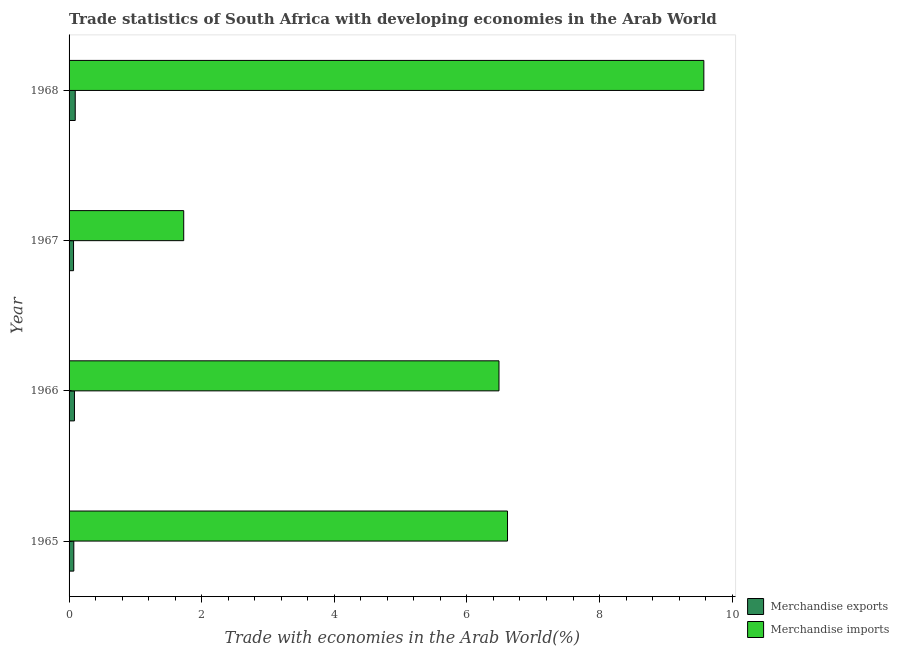Are the number of bars per tick equal to the number of legend labels?
Your answer should be very brief. Yes. How many bars are there on the 2nd tick from the bottom?
Your answer should be compact. 2. What is the label of the 3rd group of bars from the top?
Your response must be concise. 1966. In how many cases, is the number of bars for a given year not equal to the number of legend labels?
Make the answer very short. 0. What is the merchandise imports in 1965?
Ensure brevity in your answer.  6.61. Across all years, what is the maximum merchandise imports?
Keep it short and to the point. 9.57. Across all years, what is the minimum merchandise exports?
Ensure brevity in your answer.  0.07. In which year was the merchandise imports maximum?
Your answer should be very brief. 1968. In which year was the merchandise imports minimum?
Make the answer very short. 1967. What is the total merchandise imports in the graph?
Make the answer very short. 24.4. What is the difference between the merchandise exports in 1966 and that in 1967?
Make the answer very short. 0.01. What is the difference between the merchandise exports in 1967 and the merchandise imports in 1968?
Provide a succinct answer. -9.51. What is the average merchandise exports per year?
Ensure brevity in your answer.  0.08. In the year 1965, what is the difference between the merchandise exports and merchandise imports?
Your answer should be very brief. -6.54. In how many years, is the merchandise exports greater than 4 %?
Provide a short and direct response. 0. What is the ratio of the merchandise exports in 1966 to that in 1967?
Your answer should be compact. 1.21. Is the merchandise exports in 1965 less than that in 1967?
Provide a succinct answer. No. What is the difference between the highest and the second highest merchandise imports?
Your response must be concise. 2.96. What does the 2nd bar from the top in 1968 represents?
Your answer should be compact. Merchandise exports. What does the 2nd bar from the bottom in 1968 represents?
Give a very brief answer. Merchandise imports. How many bars are there?
Provide a short and direct response. 8. What is the difference between two consecutive major ticks on the X-axis?
Your response must be concise. 2. Are the values on the major ticks of X-axis written in scientific E-notation?
Ensure brevity in your answer.  No. Does the graph contain any zero values?
Offer a very short reply. No. How are the legend labels stacked?
Provide a short and direct response. Vertical. What is the title of the graph?
Your response must be concise. Trade statistics of South Africa with developing economies in the Arab World. What is the label or title of the X-axis?
Offer a terse response. Trade with economies in the Arab World(%). What is the label or title of the Y-axis?
Keep it short and to the point. Year. What is the Trade with economies in the Arab World(%) of Merchandise exports in 1965?
Provide a short and direct response. 0.07. What is the Trade with economies in the Arab World(%) in Merchandise imports in 1965?
Offer a terse response. 6.61. What is the Trade with economies in the Arab World(%) in Merchandise exports in 1966?
Your answer should be compact. 0.08. What is the Trade with economies in the Arab World(%) in Merchandise imports in 1966?
Provide a short and direct response. 6.48. What is the Trade with economies in the Arab World(%) of Merchandise exports in 1967?
Ensure brevity in your answer.  0.07. What is the Trade with economies in the Arab World(%) of Merchandise imports in 1967?
Your answer should be very brief. 1.73. What is the Trade with economies in the Arab World(%) of Merchandise exports in 1968?
Keep it short and to the point. 0.09. What is the Trade with economies in the Arab World(%) of Merchandise imports in 1968?
Make the answer very short. 9.57. Across all years, what is the maximum Trade with economies in the Arab World(%) in Merchandise exports?
Offer a very short reply. 0.09. Across all years, what is the maximum Trade with economies in the Arab World(%) in Merchandise imports?
Provide a short and direct response. 9.57. Across all years, what is the minimum Trade with economies in the Arab World(%) of Merchandise exports?
Offer a terse response. 0.07. Across all years, what is the minimum Trade with economies in the Arab World(%) of Merchandise imports?
Give a very brief answer. 1.73. What is the total Trade with economies in the Arab World(%) in Merchandise exports in the graph?
Your answer should be compact. 0.31. What is the total Trade with economies in the Arab World(%) in Merchandise imports in the graph?
Your answer should be compact. 24.4. What is the difference between the Trade with economies in the Arab World(%) of Merchandise exports in 1965 and that in 1966?
Provide a succinct answer. -0.01. What is the difference between the Trade with economies in the Arab World(%) of Merchandise imports in 1965 and that in 1966?
Provide a short and direct response. 0.13. What is the difference between the Trade with economies in the Arab World(%) in Merchandise exports in 1965 and that in 1967?
Provide a succinct answer. 0. What is the difference between the Trade with economies in the Arab World(%) of Merchandise imports in 1965 and that in 1967?
Your answer should be very brief. 4.88. What is the difference between the Trade with economies in the Arab World(%) of Merchandise exports in 1965 and that in 1968?
Ensure brevity in your answer.  -0.02. What is the difference between the Trade with economies in the Arab World(%) in Merchandise imports in 1965 and that in 1968?
Ensure brevity in your answer.  -2.96. What is the difference between the Trade with economies in the Arab World(%) in Merchandise exports in 1966 and that in 1967?
Keep it short and to the point. 0.01. What is the difference between the Trade with economies in the Arab World(%) in Merchandise imports in 1966 and that in 1967?
Your answer should be very brief. 4.75. What is the difference between the Trade with economies in the Arab World(%) in Merchandise exports in 1966 and that in 1968?
Keep it short and to the point. -0.01. What is the difference between the Trade with economies in the Arab World(%) of Merchandise imports in 1966 and that in 1968?
Your response must be concise. -3.09. What is the difference between the Trade with economies in the Arab World(%) of Merchandise exports in 1967 and that in 1968?
Provide a succinct answer. -0.03. What is the difference between the Trade with economies in the Arab World(%) in Merchandise imports in 1967 and that in 1968?
Your response must be concise. -7.84. What is the difference between the Trade with economies in the Arab World(%) of Merchandise exports in 1965 and the Trade with economies in the Arab World(%) of Merchandise imports in 1966?
Offer a terse response. -6.41. What is the difference between the Trade with economies in the Arab World(%) in Merchandise exports in 1965 and the Trade with economies in the Arab World(%) in Merchandise imports in 1967?
Ensure brevity in your answer.  -1.66. What is the difference between the Trade with economies in the Arab World(%) in Merchandise exports in 1965 and the Trade with economies in the Arab World(%) in Merchandise imports in 1968?
Offer a very short reply. -9.5. What is the difference between the Trade with economies in the Arab World(%) in Merchandise exports in 1966 and the Trade with economies in the Arab World(%) in Merchandise imports in 1967?
Provide a succinct answer. -1.65. What is the difference between the Trade with economies in the Arab World(%) of Merchandise exports in 1966 and the Trade with economies in the Arab World(%) of Merchandise imports in 1968?
Provide a succinct answer. -9.49. What is the difference between the Trade with economies in the Arab World(%) of Merchandise exports in 1967 and the Trade with economies in the Arab World(%) of Merchandise imports in 1968?
Make the answer very short. -9.51. What is the average Trade with economies in the Arab World(%) in Merchandise exports per year?
Give a very brief answer. 0.08. What is the average Trade with economies in the Arab World(%) of Merchandise imports per year?
Your response must be concise. 6.1. In the year 1965, what is the difference between the Trade with economies in the Arab World(%) in Merchandise exports and Trade with economies in the Arab World(%) in Merchandise imports?
Provide a short and direct response. -6.54. In the year 1966, what is the difference between the Trade with economies in the Arab World(%) in Merchandise exports and Trade with economies in the Arab World(%) in Merchandise imports?
Offer a terse response. -6.4. In the year 1967, what is the difference between the Trade with economies in the Arab World(%) in Merchandise exports and Trade with economies in the Arab World(%) in Merchandise imports?
Ensure brevity in your answer.  -1.66. In the year 1968, what is the difference between the Trade with economies in the Arab World(%) of Merchandise exports and Trade with economies in the Arab World(%) of Merchandise imports?
Provide a short and direct response. -9.48. What is the ratio of the Trade with economies in the Arab World(%) of Merchandise exports in 1965 to that in 1966?
Keep it short and to the point. 0.88. What is the ratio of the Trade with economies in the Arab World(%) in Merchandise imports in 1965 to that in 1966?
Provide a short and direct response. 1.02. What is the ratio of the Trade with economies in the Arab World(%) in Merchandise exports in 1965 to that in 1967?
Offer a terse response. 1.06. What is the ratio of the Trade with economies in the Arab World(%) of Merchandise imports in 1965 to that in 1967?
Ensure brevity in your answer.  3.82. What is the ratio of the Trade with economies in the Arab World(%) in Merchandise exports in 1965 to that in 1968?
Provide a short and direct response. 0.77. What is the ratio of the Trade with economies in the Arab World(%) in Merchandise imports in 1965 to that in 1968?
Your response must be concise. 0.69. What is the ratio of the Trade with economies in the Arab World(%) of Merchandise exports in 1966 to that in 1967?
Your answer should be very brief. 1.21. What is the ratio of the Trade with economies in the Arab World(%) of Merchandise imports in 1966 to that in 1967?
Keep it short and to the point. 3.75. What is the ratio of the Trade with economies in the Arab World(%) of Merchandise exports in 1966 to that in 1968?
Provide a succinct answer. 0.87. What is the ratio of the Trade with economies in the Arab World(%) in Merchandise imports in 1966 to that in 1968?
Your answer should be very brief. 0.68. What is the ratio of the Trade with economies in the Arab World(%) in Merchandise exports in 1967 to that in 1968?
Provide a short and direct response. 0.72. What is the ratio of the Trade with economies in the Arab World(%) in Merchandise imports in 1967 to that in 1968?
Provide a short and direct response. 0.18. What is the difference between the highest and the second highest Trade with economies in the Arab World(%) in Merchandise exports?
Give a very brief answer. 0.01. What is the difference between the highest and the second highest Trade with economies in the Arab World(%) of Merchandise imports?
Offer a very short reply. 2.96. What is the difference between the highest and the lowest Trade with economies in the Arab World(%) of Merchandise exports?
Provide a short and direct response. 0.03. What is the difference between the highest and the lowest Trade with economies in the Arab World(%) of Merchandise imports?
Ensure brevity in your answer.  7.84. 